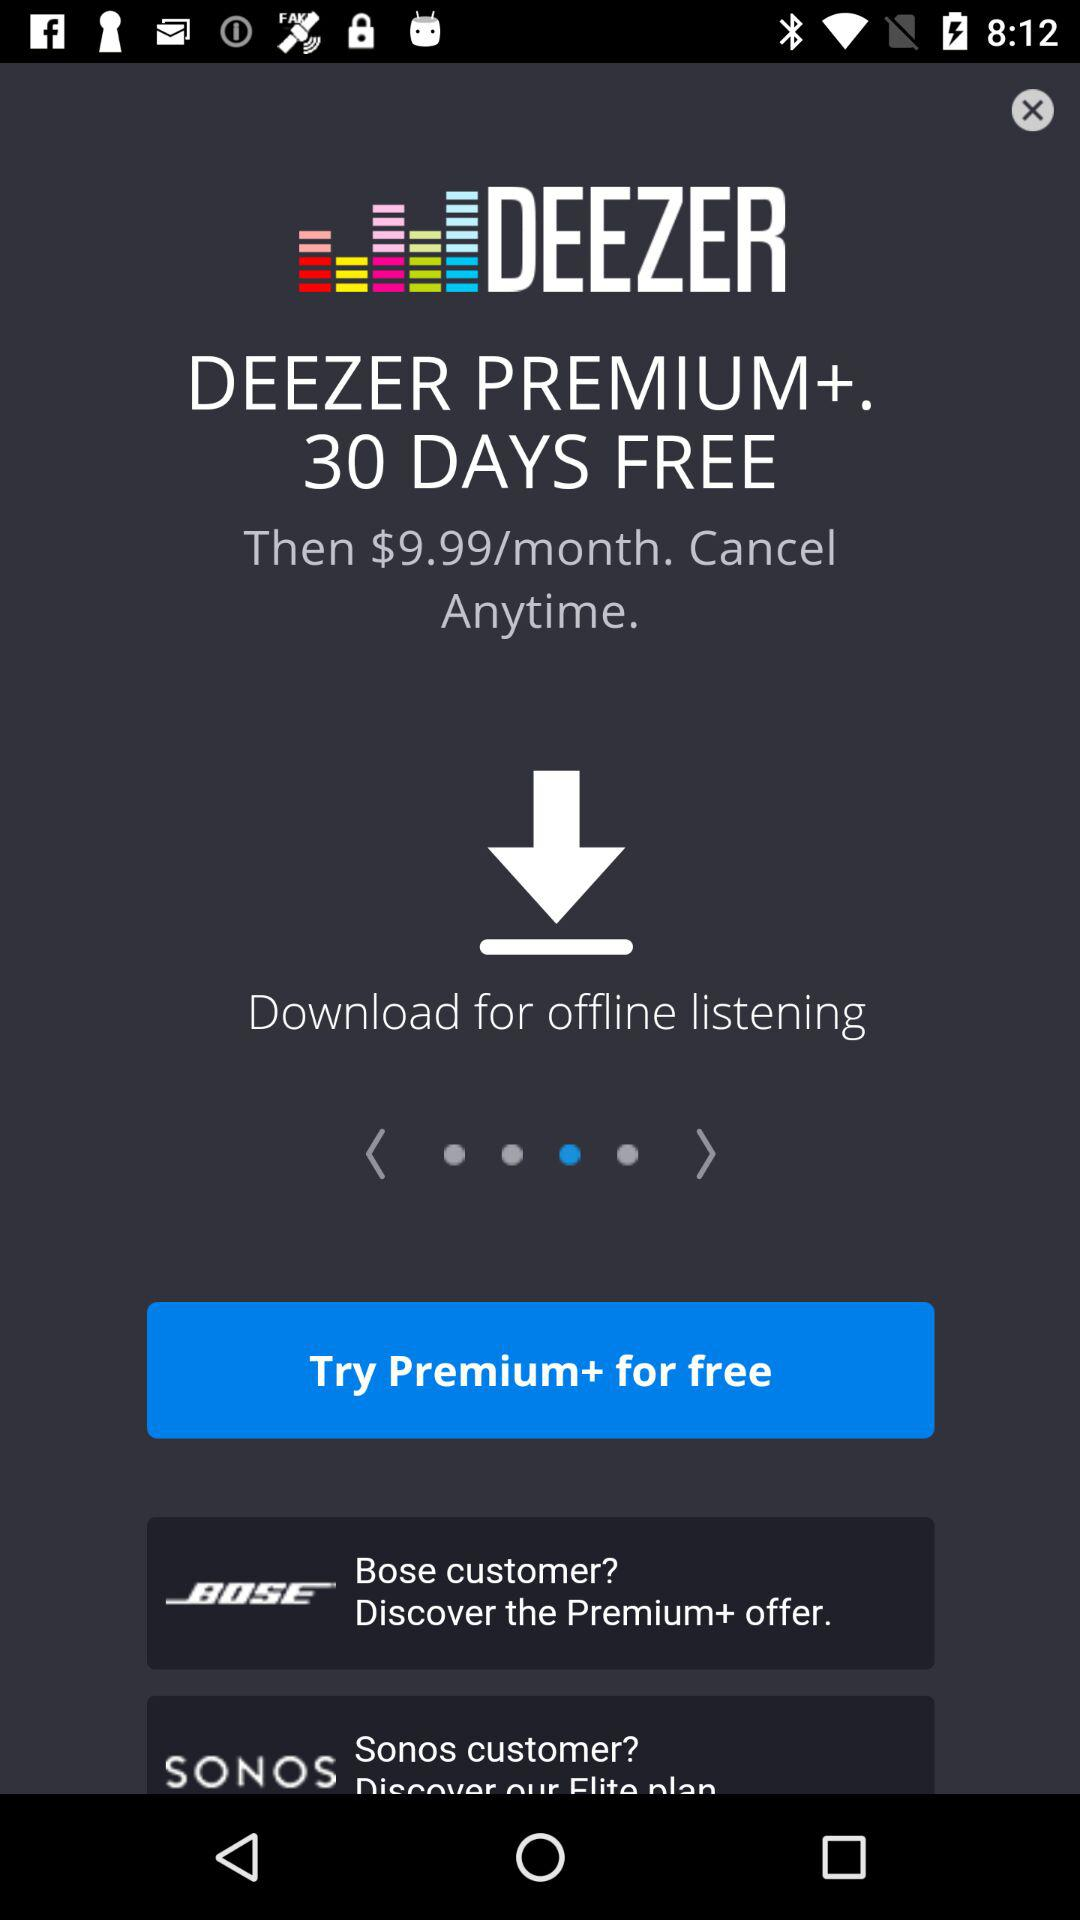For how many days is "DEEZER" premium+ free? "DEEZER" premium+ is free for 30 days. 